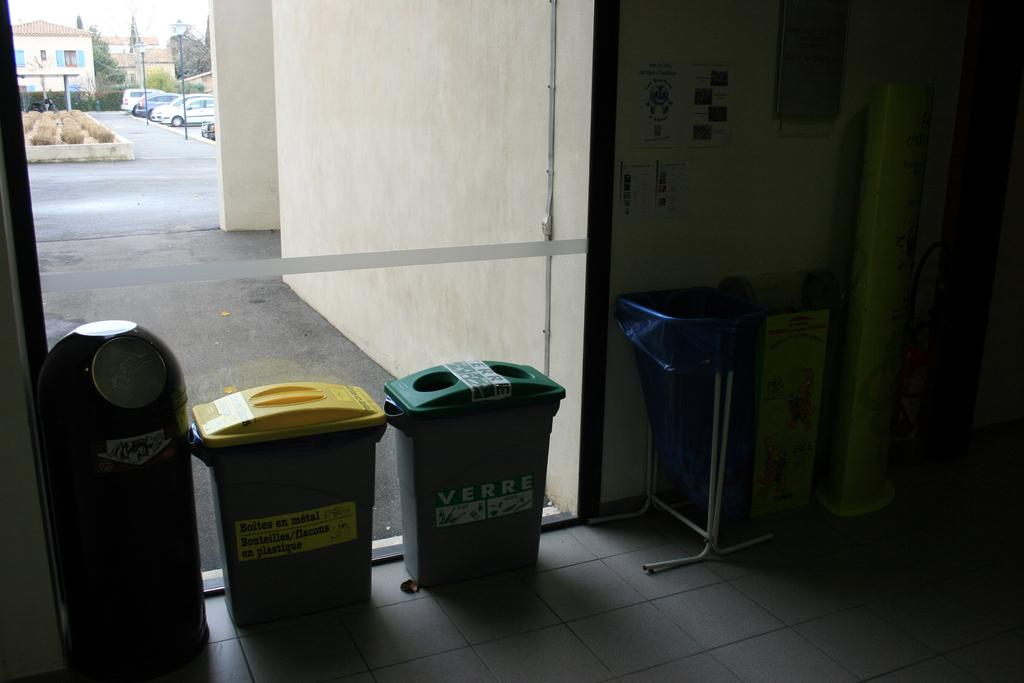<image>
Offer a succinct explanation of the picture presented. the word verre is on the side of a trash bin 